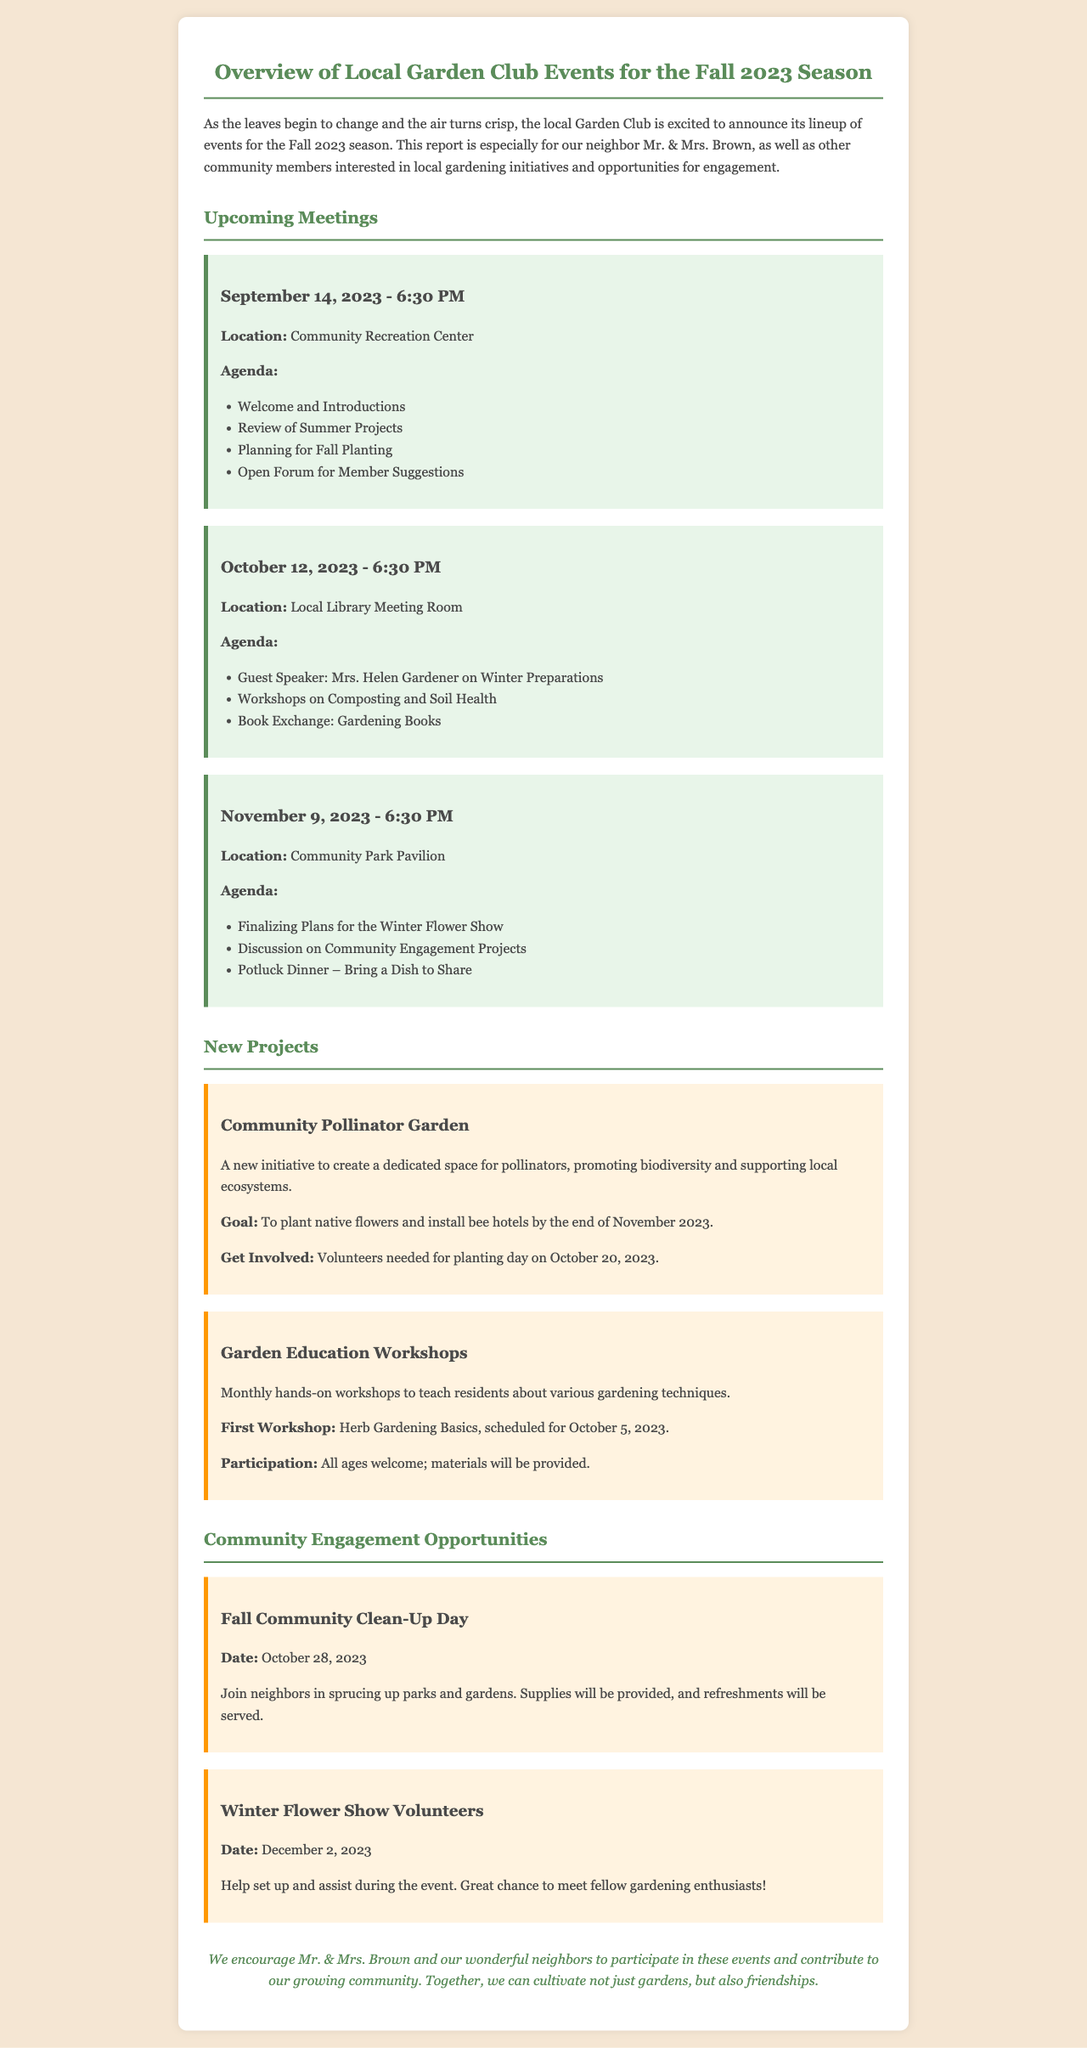What is the date of the first meeting? The first meeting is scheduled for September 14, 2023.
Answer: September 14, 2023 Who is the guest speaker for the October meeting? The guest speaker for the October meeting is Mrs. Helen Gardener.
Answer: Mrs. Helen Gardener What is the goal of the Community Pollinator Garden project? The goal is to plant native flowers and install bee hotels by the end of November 2023.
Answer: To plant native flowers and install bee hotels When is the Fall Community Clean-Up Day scheduled? The Fall Community Clean-Up Day is scheduled for October 28, 2023.
Answer: October 28, 2023 What type of event is happening on November 9, 2023? The event is focused on finalizing plans for the Winter Flower Show.
Answer: Winter Flower Show How often are the Garden Education Workshops held? The Garden Education Workshops are held monthly.
Answer: Monthly What is required from volunteers for the planting day? Volunteers are needed for the planting day on October 20, 2023.
Answer: Volunteers What type of dinner is planned for the November meeting? A potluck dinner is planned, and members are encouraged to bring a dish to share.
Answer: Potluck dinner 